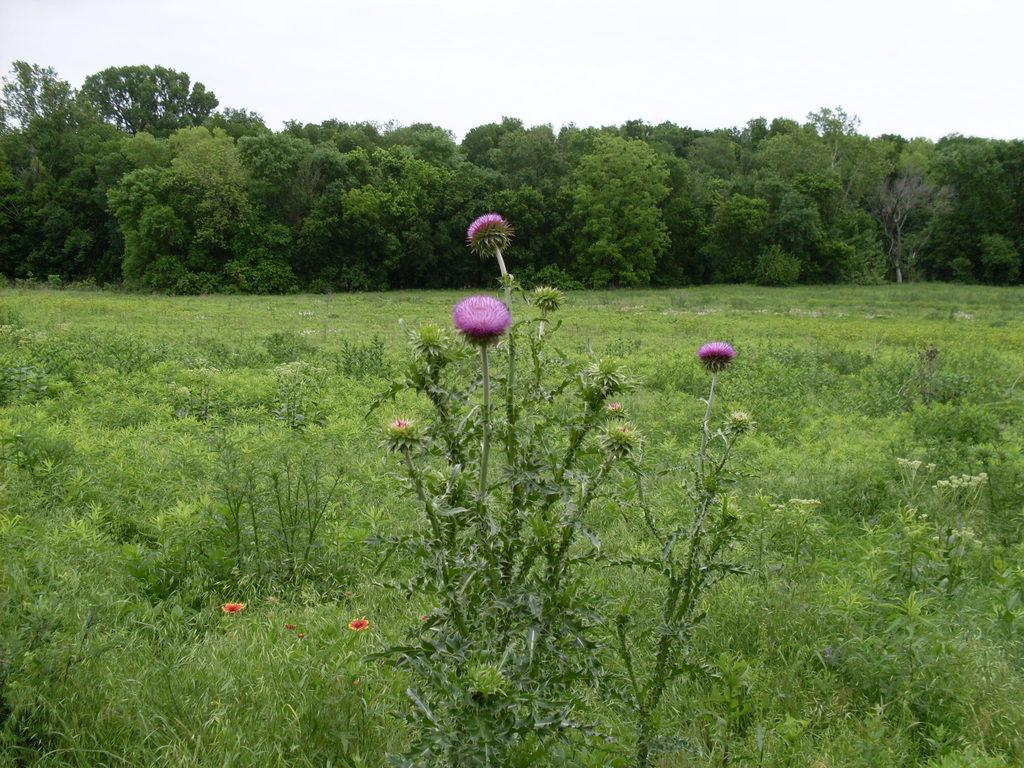What type of vegetation can be seen in the image? There are plants, flowers, trees, and grass in the image. Can you describe the natural environment depicted in the image? The image features plants, flowers, trees, and grass, with the sky visible in the background. What type of terrain is present in the image? The terrain in the image includes grass and possibly other types of vegetation. How many sticks can be seen in the image? There are no sticks present in the image. What type of animal is using its fang to dig in the image? There are no animals or fangs present in the image. 